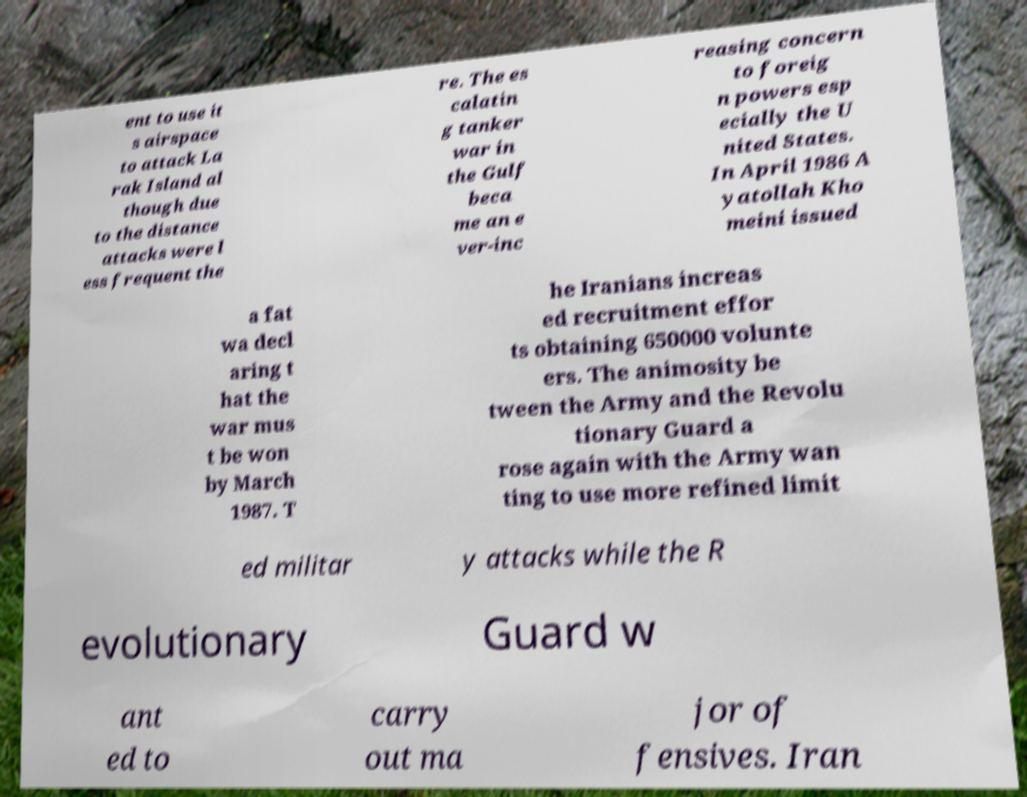For documentation purposes, I need the text within this image transcribed. Could you provide that? ent to use it s airspace to attack La rak Island al though due to the distance attacks were l ess frequent the re. The es calatin g tanker war in the Gulf beca me an e ver-inc reasing concern to foreig n powers esp ecially the U nited States. In April 1986 A yatollah Kho meini issued a fat wa decl aring t hat the war mus t be won by March 1987. T he Iranians increas ed recruitment effor ts obtaining 650000 volunte ers. The animosity be tween the Army and the Revolu tionary Guard a rose again with the Army wan ting to use more refined limit ed militar y attacks while the R evolutionary Guard w ant ed to carry out ma jor of fensives. Iran 